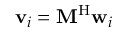Convert formula to latex. <formula><loc_0><loc_0><loc_500><loc_500>v _ { i } = M ^ { H } w _ { i }</formula> 